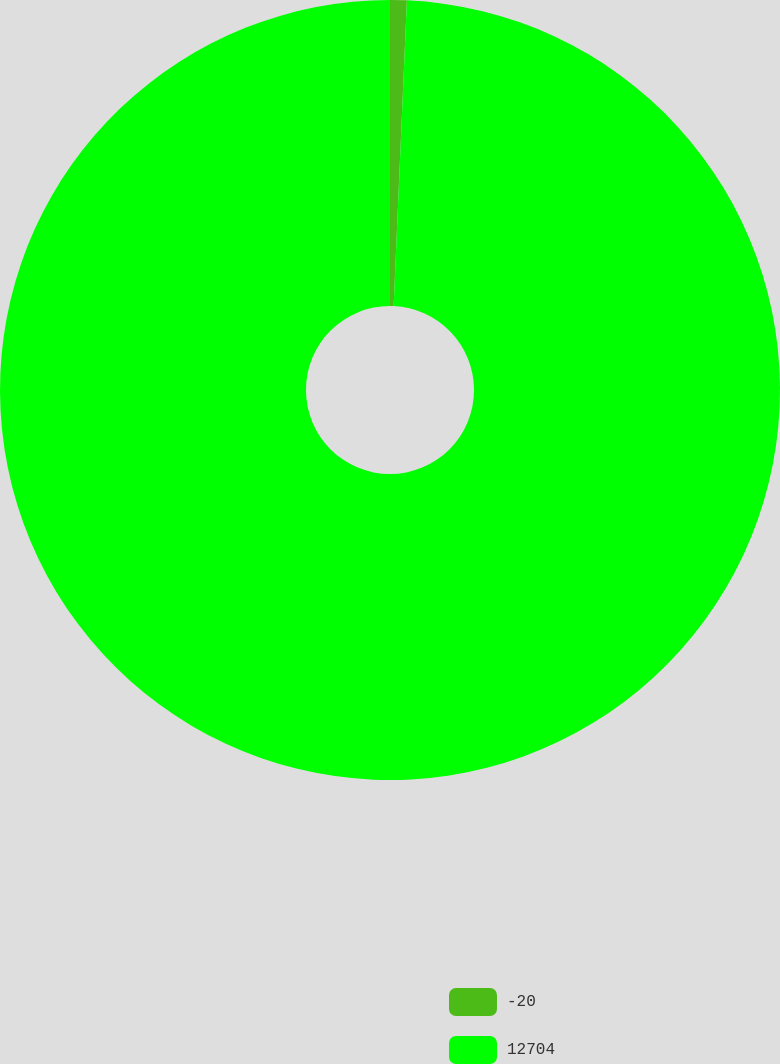Convert chart to OTSL. <chart><loc_0><loc_0><loc_500><loc_500><pie_chart><fcel>-20<fcel>12704<nl><fcel>0.69%<fcel>99.31%<nl></chart> 